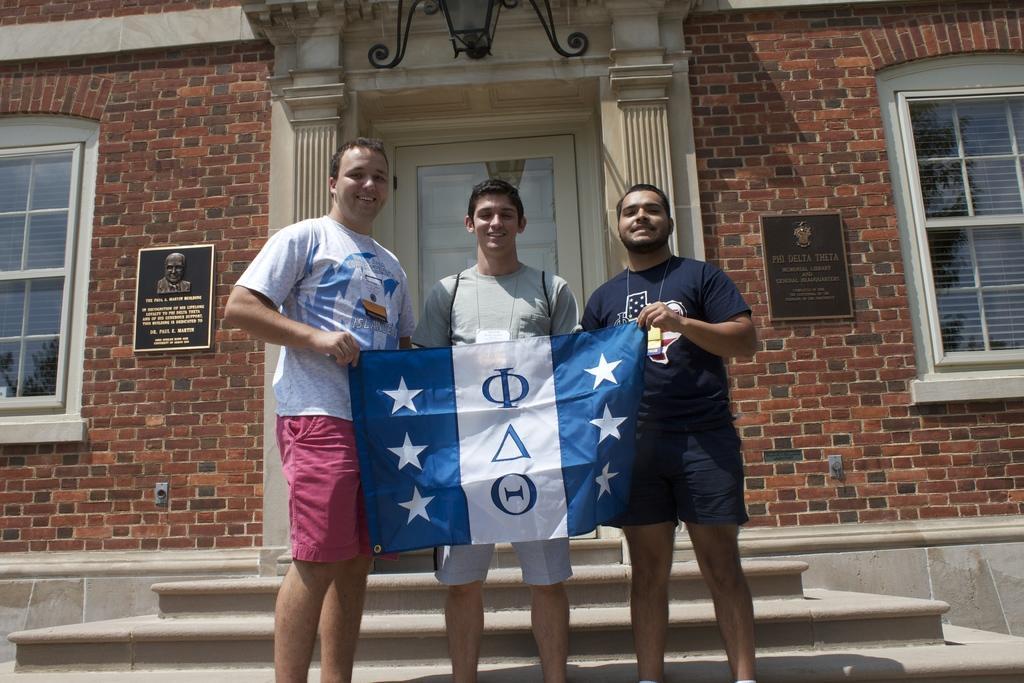In one or two sentences, can you explain what this image depicts? 3 people are standing holding a flag in their hands. Behind them there are stairs and a buildings. The building has a door at the center, 2 windows, a lamp and 2 photo frames. 